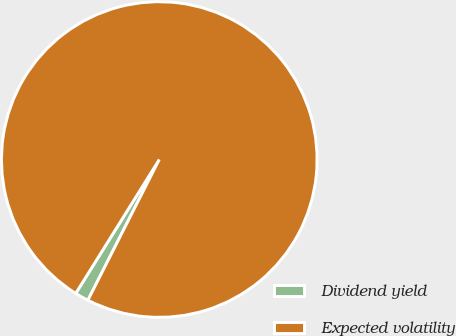Convert chart to OTSL. <chart><loc_0><loc_0><loc_500><loc_500><pie_chart><fcel>Dividend yield<fcel>Expected volatility<nl><fcel>1.41%<fcel>98.59%<nl></chart> 